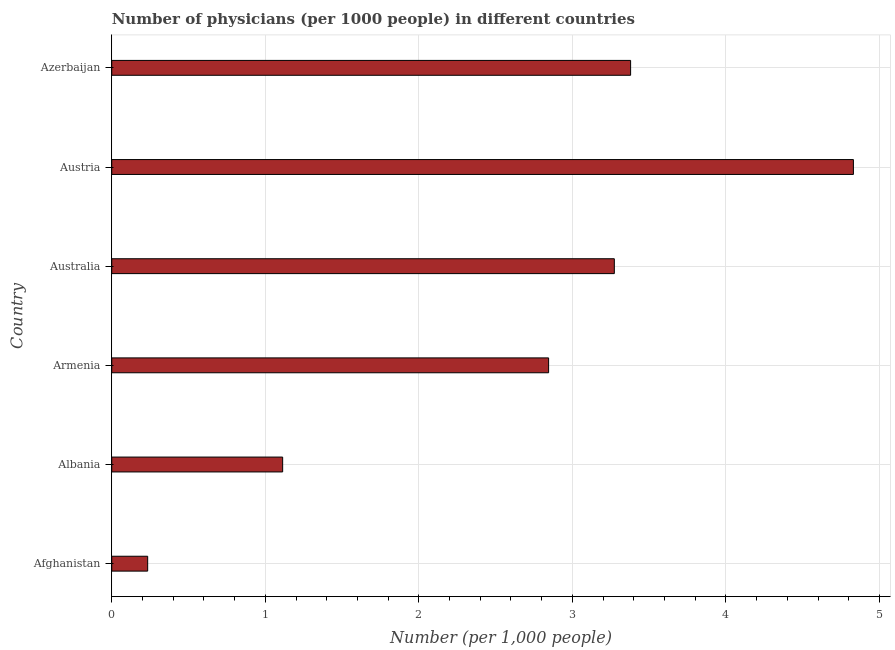Does the graph contain any zero values?
Your answer should be very brief. No. What is the title of the graph?
Provide a short and direct response. Number of physicians (per 1000 people) in different countries. What is the label or title of the X-axis?
Give a very brief answer. Number (per 1,0 people). What is the label or title of the Y-axis?
Provide a succinct answer. Country. What is the number of physicians in Austria?
Offer a very short reply. 4.83. Across all countries, what is the maximum number of physicians?
Offer a very short reply. 4.83. Across all countries, what is the minimum number of physicians?
Provide a succinct answer. 0.23. In which country was the number of physicians maximum?
Provide a succinct answer. Austria. In which country was the number of physicians minimum?
Make the answer very short. Afghanistan. What is the sum of the number of physicians?
Make the answer very short. 15.67. What is the difference between the number of physicians in Austria and Azerbaijan?
Offer a terse response. 1.45. What is the average number of physicians per country?
Provide a short and direct response. 2.61. What is the median number of physicians?
Your answer should be very brief. 3.06. In how many countries, is the number of physicians greater than 3.6 ?
Ensure brevity in your answer.  1. What is the ratio of the number of physicians in Austria to that in Azerbaijan?
Your answer should be very brief. 1.43. Is the number of physicians in Albania less than that in Armenia?
Keep it short and to the point. Yes. What is the difference between the highest and the second highest number of physicians?
Provide a succinct answer. 1.45. Is the sum of the number of physicians in Afghanistan and Armenia greater than the maximum number of physicians across all countries?
Provide a short and direct response. No. How many countries are there in the graph?
Offer a very short reply. 6. What is the Number (per 1,000 people) in Afghanistan?
Provide a succinct answer. 0.23. What is the Number (per 1,000 people) of Albania?
Give a very brief answer. 1.11. What is the Number (per 1,000 people) of Armenia?
Provide a short and direct response. 2.85. What is the Number (per 1,000 people) of Australia?
Your answer should be very brief. 3.27. What is the Number (per 1,000 people) of Austria?
Ensure brevity in your answer.  4.83. What is the Number (per 1,000 people) of Azerbaijan?
Offer a very short reply. 3.38. What is the difference between the Number (per 1,000 people) in Afghanistan and Albania?
Make the answer very short. -0.88. What is the difference between the Number (per 1,000 people) in Afghanistan and Armenia?
Offer a terse response. -2.61. What is the difference between the Number (per 1,000 people) in Afghanistan and Australia?
Your answer should be compact. -3.04. What is the difference between the Number (per 1,000 people) in Afghanistan and Austria?
Make the answer very short. -4.6. What is the difference between the Number (per 1,000 people) in Afghanistan and Azerbaijan?
Ensure brevity in your answer.  -3.15. What is the difference between the Number (per 1,000 people) in Albania and Armenia?
Give a very brief answer. -1.73. What is the difference between the Number (per 1,000 people) in Albania and Australia?
Offer a very short reply. -2.16. What is the difference between the Number (per 1,000 people) in Albania and Austria?
Ensure brevity in your answer.  -3.72. What is the difference between the Number (per 1,000 people) in Albania and Azerbaijan?
Offer a very short reply. -2.27. What is the difference between the Number (per 1,000 people) in Armenia and Australia?
Your answer should be compact. -0.43. What is the difference between the Number (per 1,000 people) in Armenia and Austria?
Make the answer very short. -1.99. What is the difference between the Number (per 1,000 people) in Armenia and Azerbaijan?
Offer a very short reply. -0.53. What is the difference between the Number (per 1,000 people) in Australia and Austria?
Ensure brevity in your answer.  -1.56. What is the difference between the Number (per 1,000 people) in Australia and Azerbaijan?
Your answer should be compact. -0.11. What is the difference between the Number (per 1,000 people) in Austria and Azerbaijan?
Your answer should be very brief. 1.45. What is the ratio of the Number (per 1,000 people) in Afghanistan to that in Albania?
Provide a succinct answer. 0.21. What is the ratio of the Number (per 1,000 people) in Afghanistan to that in Armenia?
Your answer should be very brief. 0.08. What is the ratio of the Number (per 1,000 people) in Afghanistan to that in Australia?
Provide a short and direct response. 0.07. What is the ratio of the Number (per 1,000 people) in Afghanistan to that in Austria?
Ensure brevity in your answer.  0.05. What is the ratio of the Number (per 1,000 people) in Afghanistan to that in Azerbaijan?
Provide a short and direct response. 0.07. What is the ratio of the Number (per 1,000 people) in Albania to that in Armenia?
Provide a succinct answer. 0.39. What is the ratio of the Number (per 1,000 people) in Albania to that in Australia?
Give a very brief answer. 0.34. What is the ratio of the Number (per 1,000 people) in Albania to that in Austria?
Provide a succinct answer. 0.23. What is the ratio of the Number (per 1,000 people) in Albania to that in Azerbaijan?
Your answer should be compact. 0.33. What is the ratio of the Number (per 1,000 people) in Armenia to that in Australia?
Your answer should be compact. 0.87. What is the ratio of the Number (per 1,000 people) in Armenia to that in Austria?
Give a very brief answer. 0.59. What is the ratio of the Number (per 1,000 people) in Armenia to that in Azerbaijan?
Your answer should be very brief. 0.84. What is the ratio of the Number (per 1,000 people) in Australia to that in Austria?
Make the answer very short. 0.68. What is the ratio of the Number (per 1,000 people) in Australia to that in Azerbaijan?
Provide a short and direct response. 0.97. What is the ratio of the Number (per 1,000 people) in Austria to that in Azerbaijan?
Your answer should be compact. 1.43. 